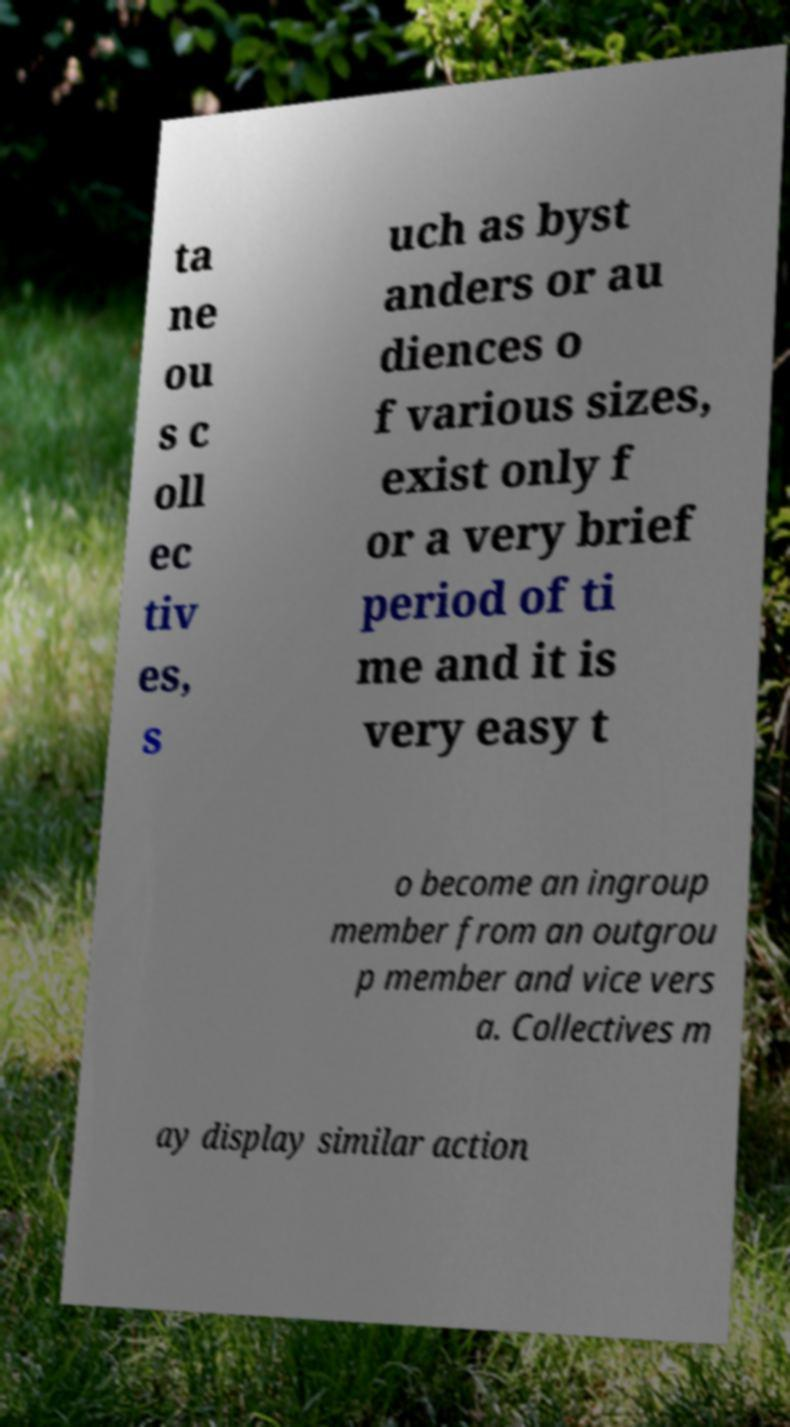There's text embedded in this image that I need extracted. Can you transcribe it verbatim? ta ne ou s c oll ec tiv es, s uch as byst anders or au diences o f various sizes, exist only f or a very brief period of ti me and it is very easy t o become an ingroup member from an outgrou p member and vice vers a. Collectives m ay display similar action 